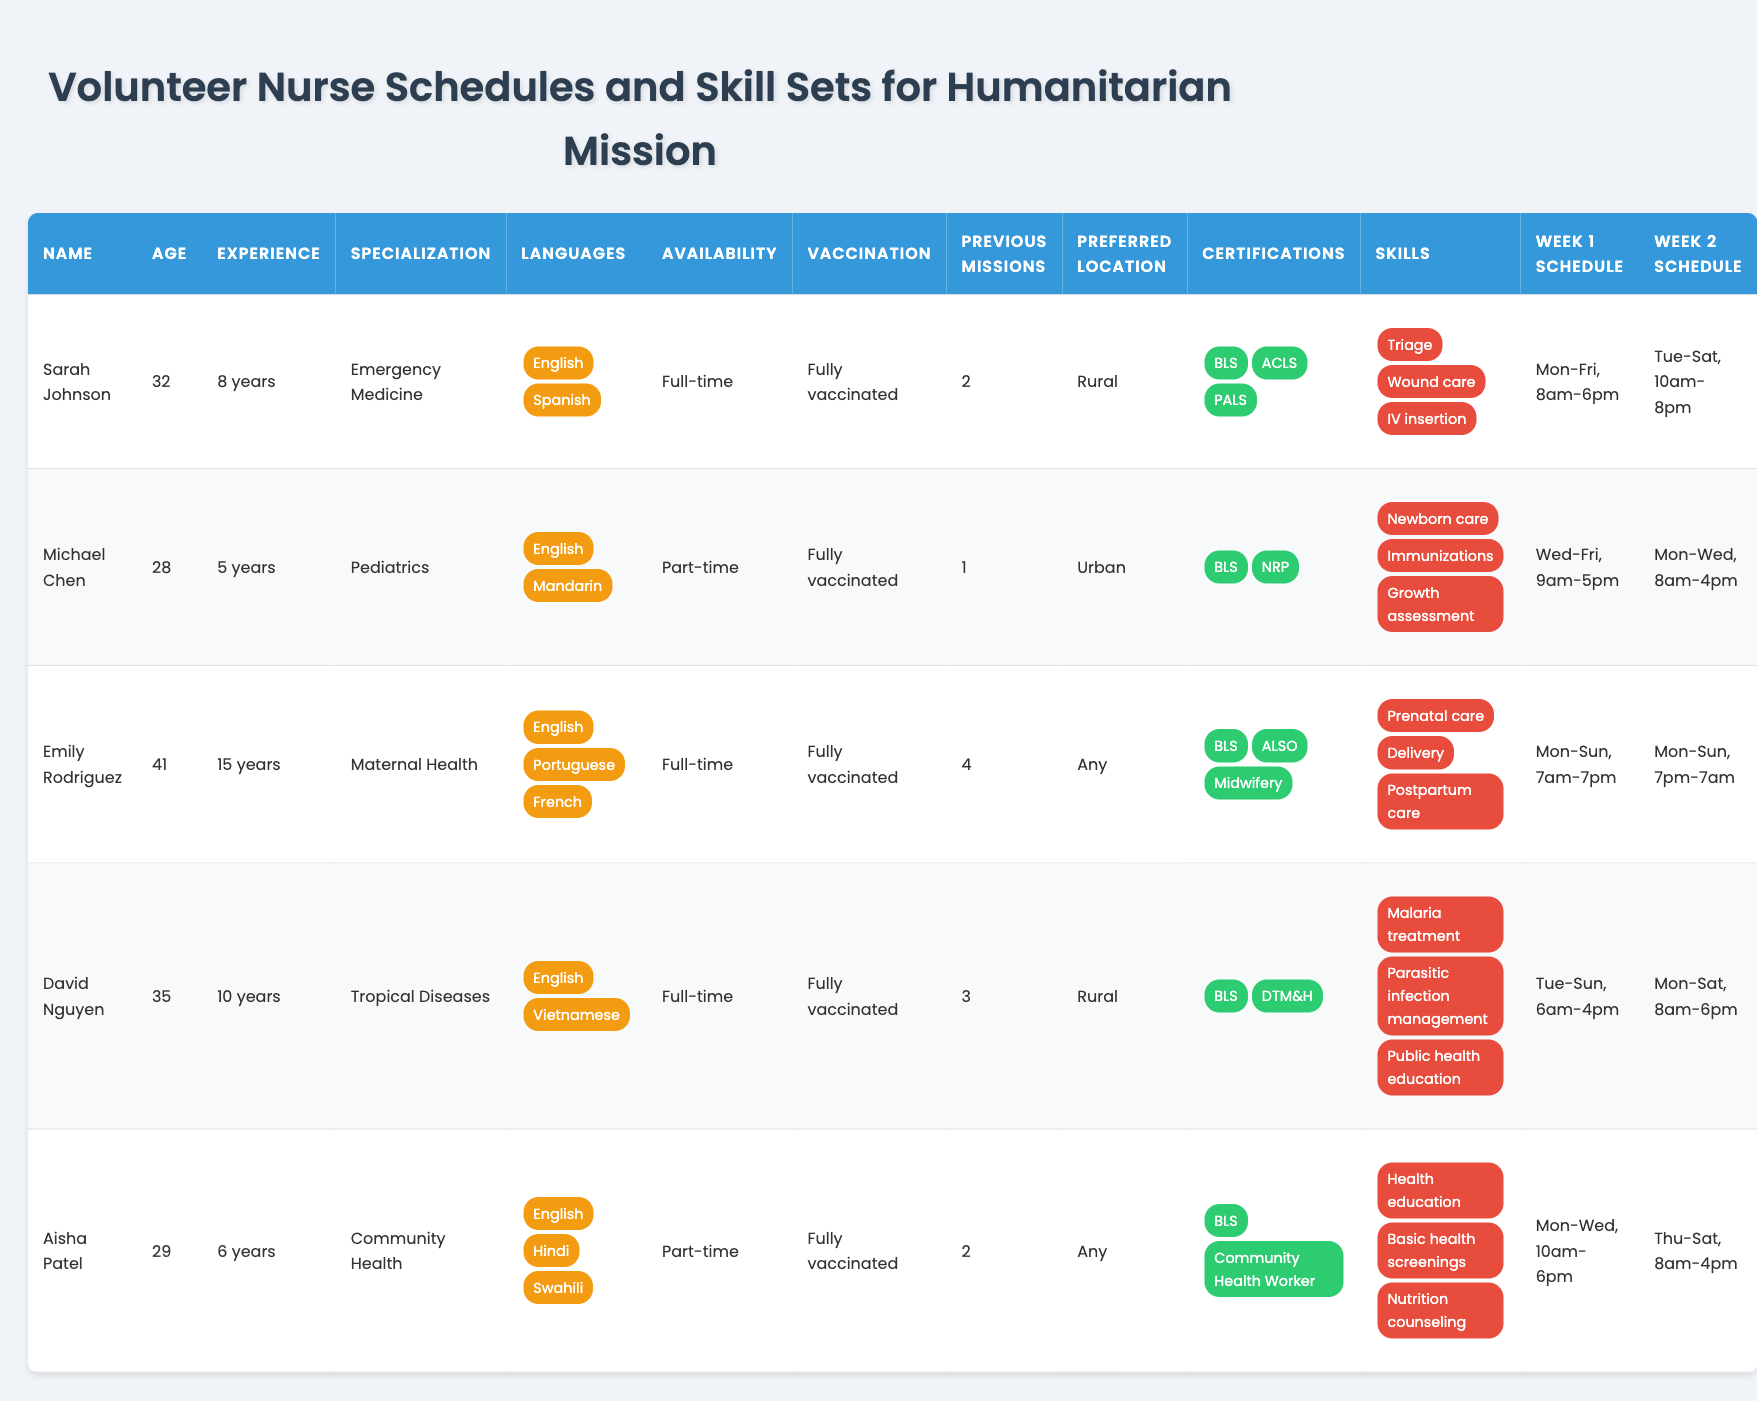What is the age of Emily Rodriguez? From the table, we can locate Emily Rodriguez and see that her age is listed as 41.
Answer: 41 How many years of experience does David Nguyen have? Looking at the table, David Nguyen's entry shows that he has 10 years of experience.
Answer: 10 Which volunteer specializes in Pediatrics? By scanning the specialization column, we find that Michael Chen is the volunteer who specializes in Pediatrics.
Answer: Michael Chen List the languages spoken by Sarah Johnson. Referring to Sarah Johnson's entry, the languages she speaks are English and Spanish as shown in the languages column.
Answer: English, Spanish Is Aisha Patel available full-time? By checking Aisha Patel's availability status in the table, it indicates that she is available for part-time work.
Answer: No What is the preferred location of Emily Rodriguez? By examining Emily's entry in the preferred location column, we see that she is open to working in any location.
Answer: Any How many previous missions has David Nguyen participated in? From the previous missions column, David Nguyen has participated in three missions as stated in the data.
Answer: 3 Which volunteer has the most years of experience? By comparing the years of experience across all volunteers, Emily Rodriguez has the most at 15 years.
Answer: Emily Rodriguez How many languages can Aisha Patel communicate in? Checking Aisha Patel's entry, she speaks three languages: English, Hindi, and Swahili, as shown in the languages section.
Answer: 3 What are the two certifications that Michael Chen holds? Looking at Michael Chen’s certifications, he has BLS and NRP listed.
Answer: BLS, NRP Which volunteers are available full-time? By scanning the availability column, Sarah Johnson, Emily Rodriguez, and David Nguyen are identified as available full-time.
Answer: Sarah Johnson, Emily Rodriguez, David Nguyen Calculate the total years of experience of all volunteers combined. Summing the years of experience: 8 + 5 + 15 + 10 + 6 = 44 years of collective experience from all volunteers.
Answer: 44 Is it true that all volunteers are fully vaccinated? By closely analyzing the vaccination status for each volunteer, we find that they are all listed as fully vaccinated, hence the statement holds true.
Answer: Yes What is the common skill among all volunteers? Upon examining the skills, "BLS" certification appears to be common in the certifications of most volunteers, indicating a shared proficiency.
Answer: BLS (implied as common certification/skill) After reviewing the schedules for week 1, which volunteer works on the weekend? Looking at the week 1 schedule, both Emily Rodriguez and David Nguyen work on the weekend (Saturday and Sunday).
Answer: Emily Rodriguez, David Nguyen Which specialization has the highest number of years of experience among volunteers? By comparing experience, Maternal Health (Emily Rodriguez with 15 years) has the highest among the specializations listed.
Answer: Maternal Health 